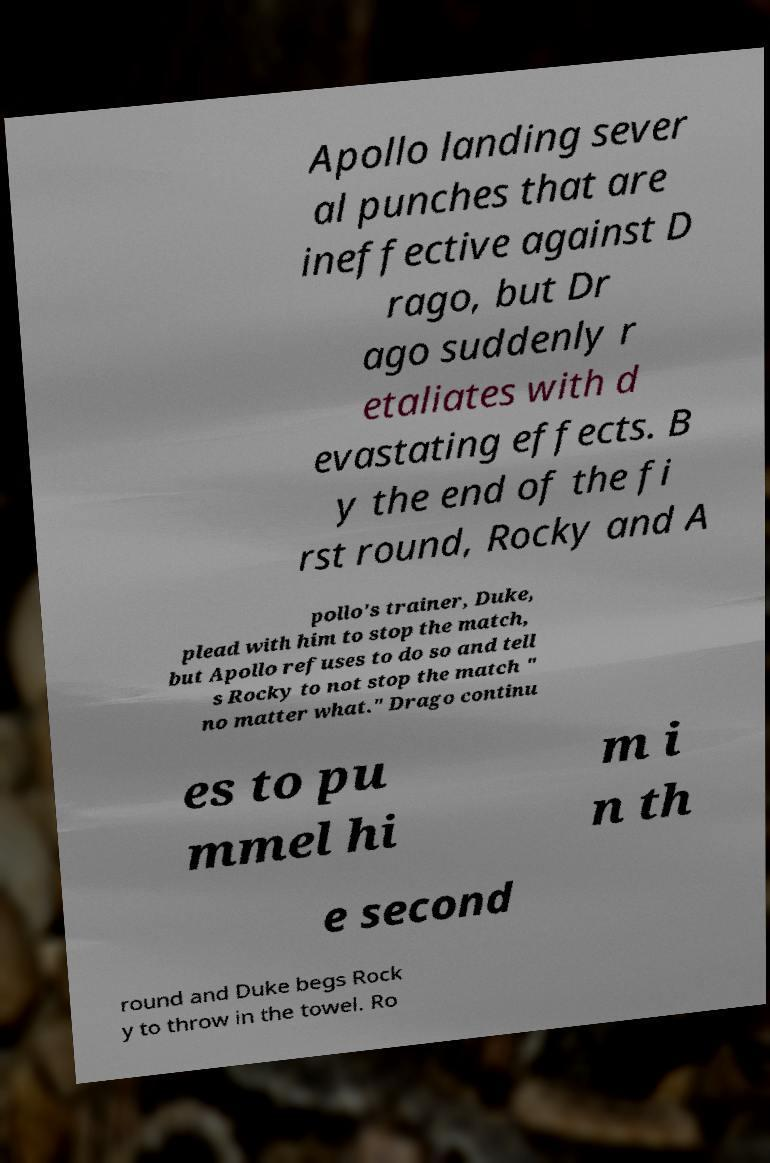Could you assist in decoding the text presented in this image and type it out clearly? Apollo landing sever al punches that are ineffective against D rago, but Dr ago suddenly r etaliates with d evastating effects. B y the end of the fi rst round, Rocky and A pollo's trainer, Duke, plead with him to stop the match, but Apollo refuses to do so and tell s Rocky to not stop the match " no matter what." Drago continu es to pu mmel hi m i n th e second round and Duke begs Rock y to throw in the towel. Ro 